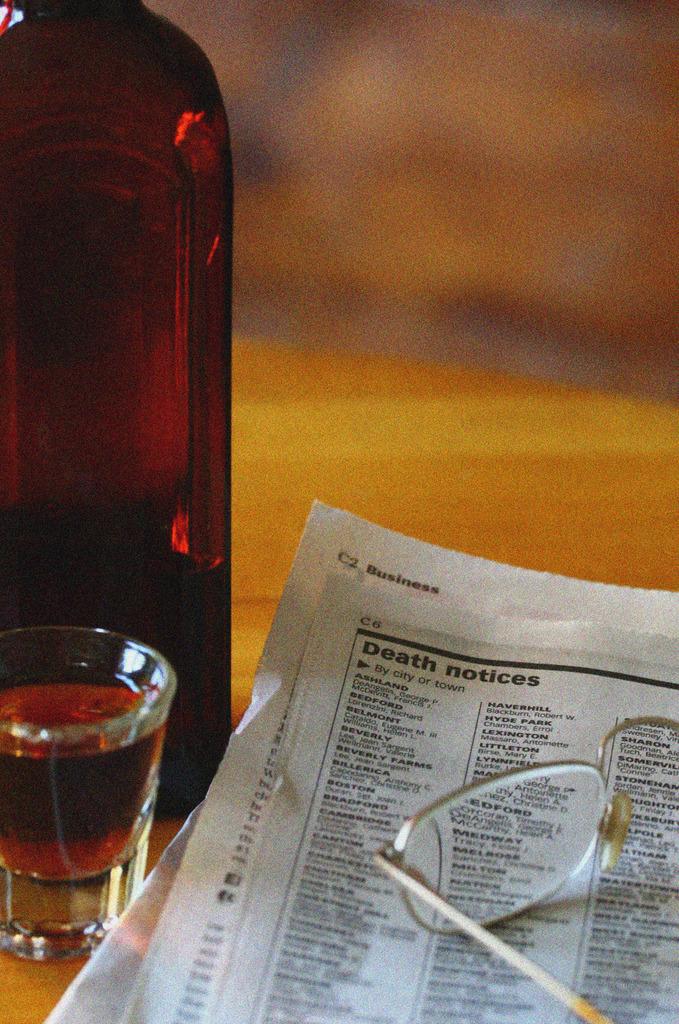Are they reading death notices?
Give a very brief answer. Yes. What is this chart all about?
Provide a succinct answer. Death notices. 